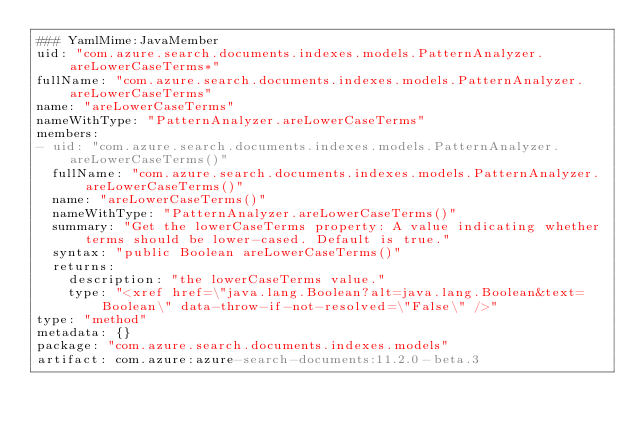Convert code to text. <code><loc_0><loc_0><loc_500><loc_500><_YAML_>### YamlMime:JavaMember
uid: "com.azure.search.documents.indexes.models.PatternAnalyzer.areLowerCaseTerms*"
fullName: "com.azure.search.documents.indexes.models.PatternAnalyzer.areLowerCaseTerms"
name: "areLowerCaseTerms"
nameWithType: "PatternAnalyzer.areLowerCaseTerms"
members:
- uid: "com.azure.search.documents.indexes.models.PatternAnalyzer.areLowerCaseTerms()"
  fullName: "com.azure.search.documents.indexes.models.PatternAnalyzer.areLowerCaseTerms()"
  name: "areLowerCaseTerms()"
  nameWithType: "PatternAnalyzer.areLowerCaseTerms()"
  summary: "Get the lowerCaseTerms property: A value indicating whether terms should be lower-cased. Default is true."
  syntax: "public Boolean areLowerCaseTerms()"
  returns:
    description: "the lowerCaseTerms value."
    type: "<xref href=\"java.lang.Boolean?alt=java.lang.Boolean&text=Boolean\" data-throw-if-not-resolved=\"False\" />"
type: "method"
metadata: {}
package: "com.azure.search.documents.indexes.models"
artifact: com.azure:azure-search-documents:11.2.0-beta.3
</code> 